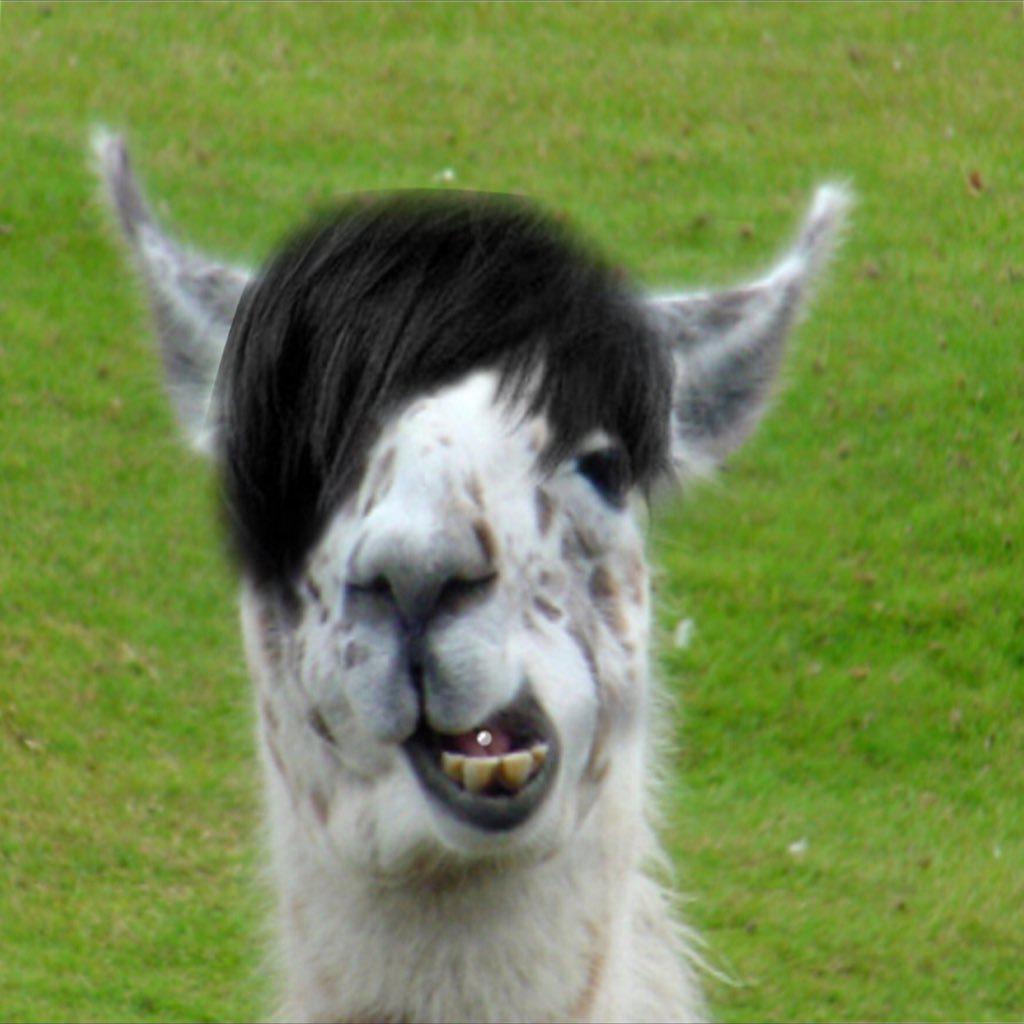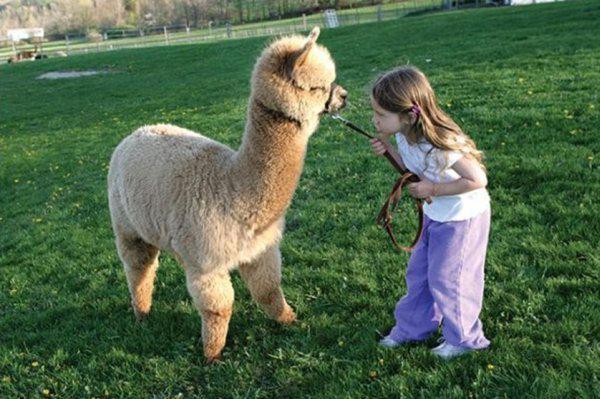The first image is the image on the left, the second image is the image on the right. Evaluate the accuracy of this statement regarding the images: "At least one llama has food in its mouth.". Is it true? Answer yes or no. No. The first image is the image on the left, the second image is the image on the right. Considering the images on both sides, is "There are three mammals in total." valid? Answer yes or no. Yes. 